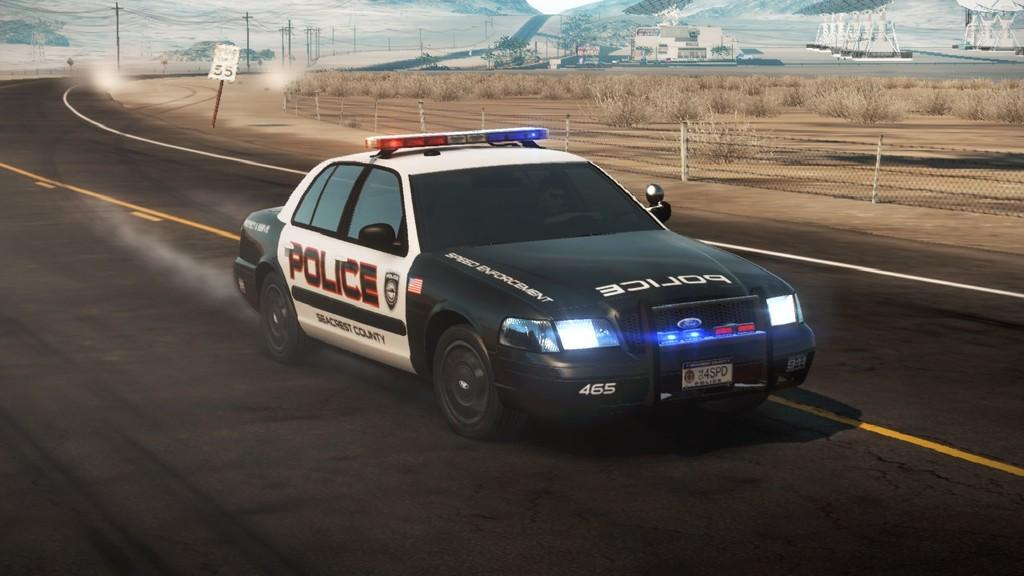What type of vehicle is on the road in the image? There is a police car on the road in the image. What is surrounding the police car? There is fencing around the car. What can be seen near the police car? Dry plants are present near the car. What structures are visible in the image? Poles are visible in the image. What is visible in the background of the image? There are trees in the background of the image. What type of bun is being served by the maid in the image? There is no bun or maid present in the image; it features a police car on the road with fencing, dry plants, poles, and trees in the background. 